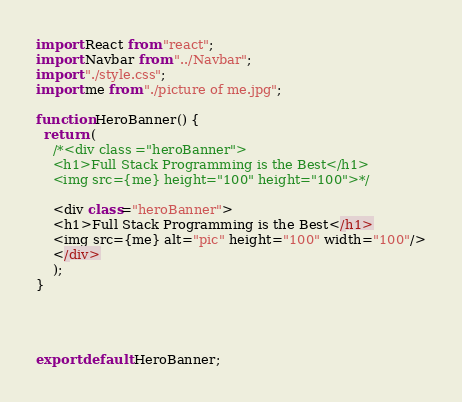Convert code to text. <code><loc_0><loc_0><loc_500><loc_500><_JavaScript_>import React from "react";
import Navbar from "../Navbar";
import "./style.css";
import me from "./picture of me.jpg";

function HeroBanner() {
  return (
    /*<div class ="heroBanner">
    <h1>Full Stack Programming is the Best</h1>
    <img src={me} height="100" height="100">*/
  
    <div class="heroBanner">
    <h1>Full Stack Programming is the Best</h1>
    <img src={me} alt="pic" height="100" width="100"/>
    </div>
    );
}

     
 

export default HeroBanner;
</code> 